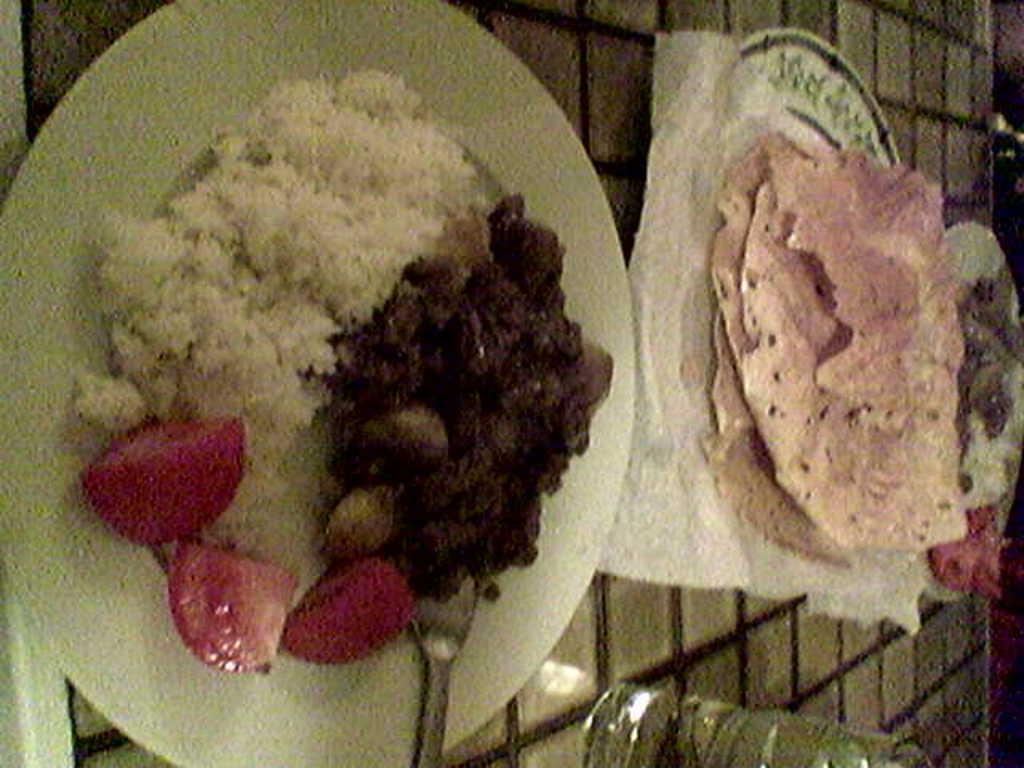What piece of furniture is present in the image? There is a table in the image. How many plates are on the table? There are three plates on the table. What is on the plates? The plates contain food items. What type of beverage is in the glass on the table? There is a glass of water on the table. What utensil is present on one of the plates? There is a spoon on one of the plates. Can you see any mice running around on the table in the image? No, there are no mice present in the image. Is there a horse sitting at the table in the image? No, there is no horse present in the image. 